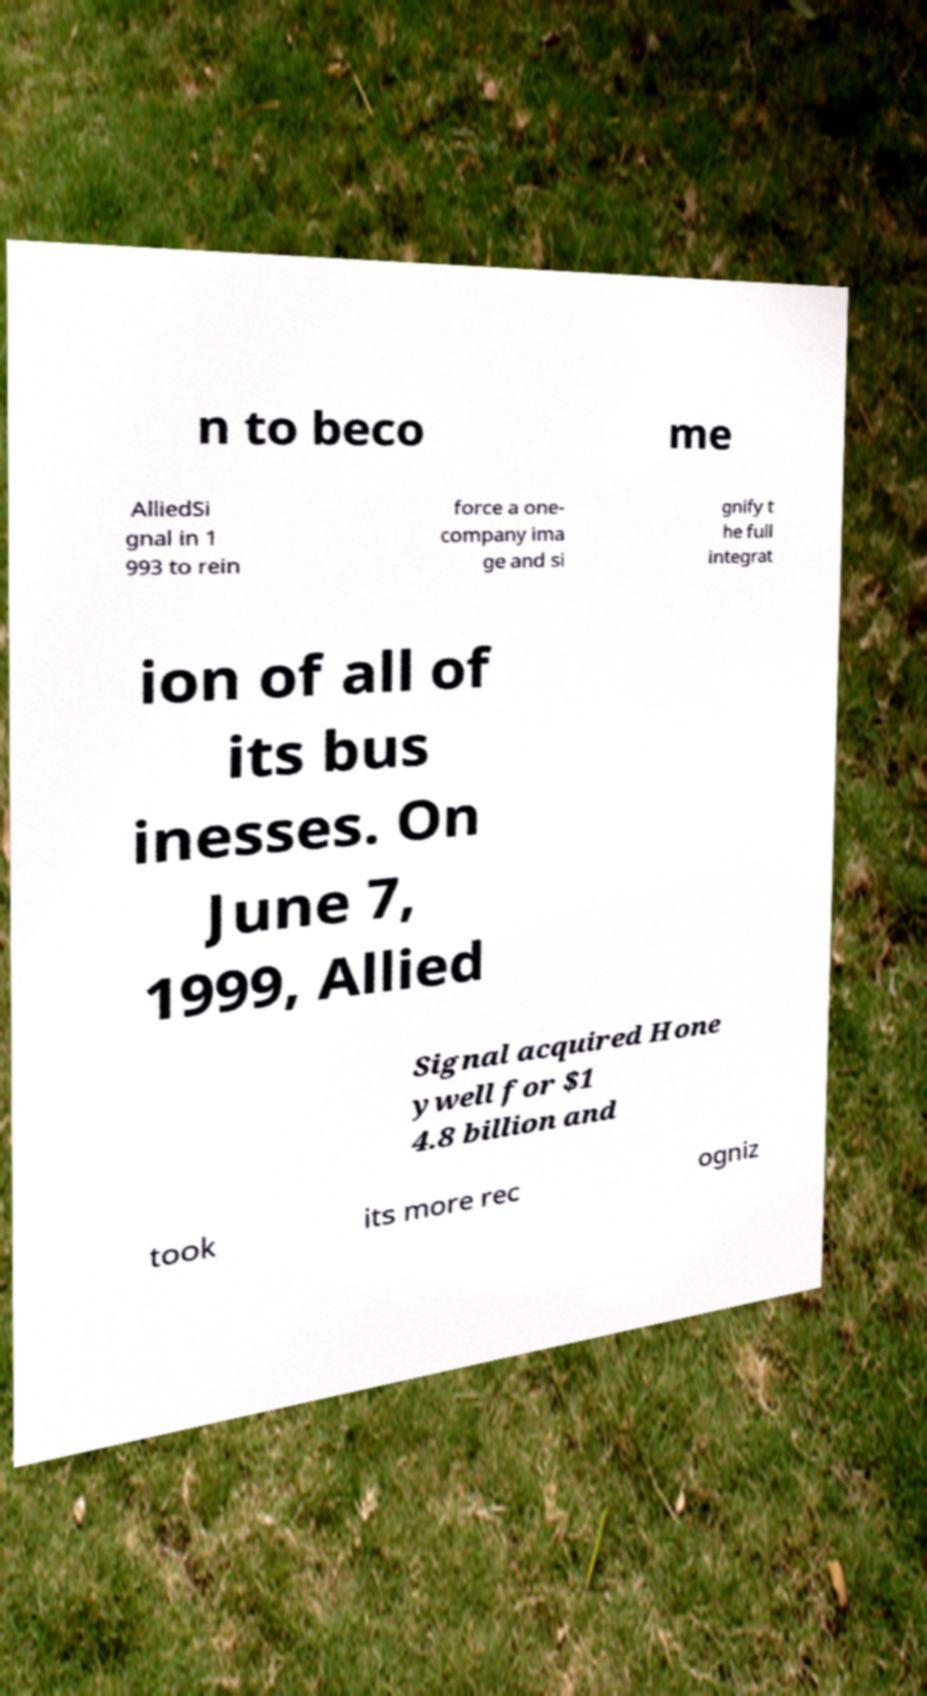I need the written content from this picture converted into text. Can you do that? n to beco me AlliedSi gnal in 1 993 to rein force a one- company ima ge and si gnify t he full integrat ion of all of its bus inesses. On June 7, 1999, Allied Signal acquired Hone ywell for $1 4.8 billion and took its more rec ogniz 